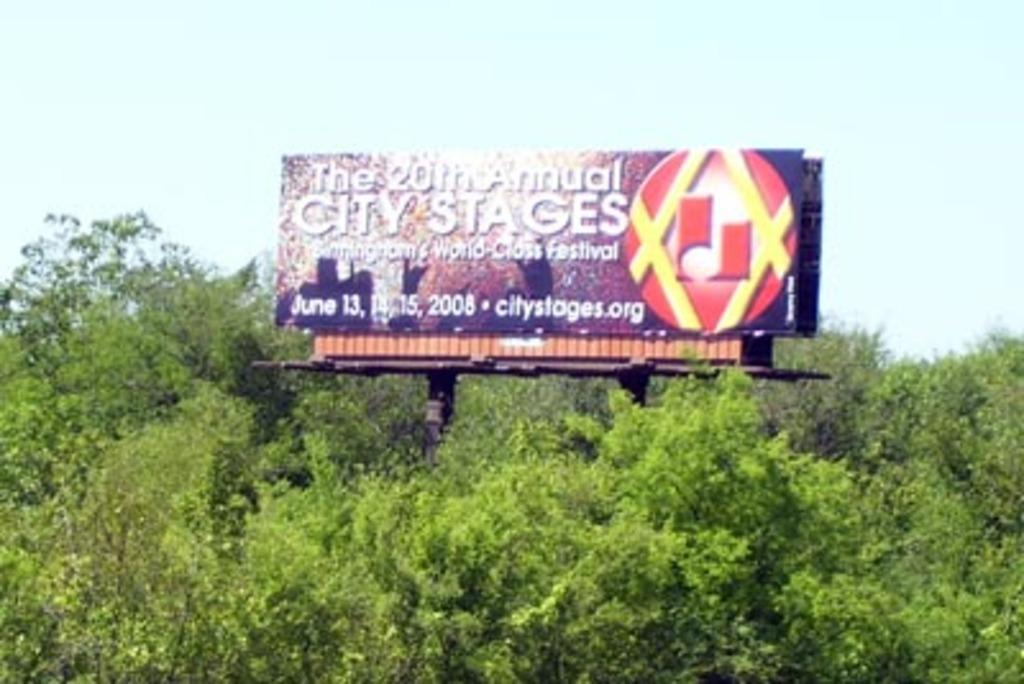Provide a one-sentence caption for the provided image. A billboard for the 20th annual City Stages festival rises above the trees. 